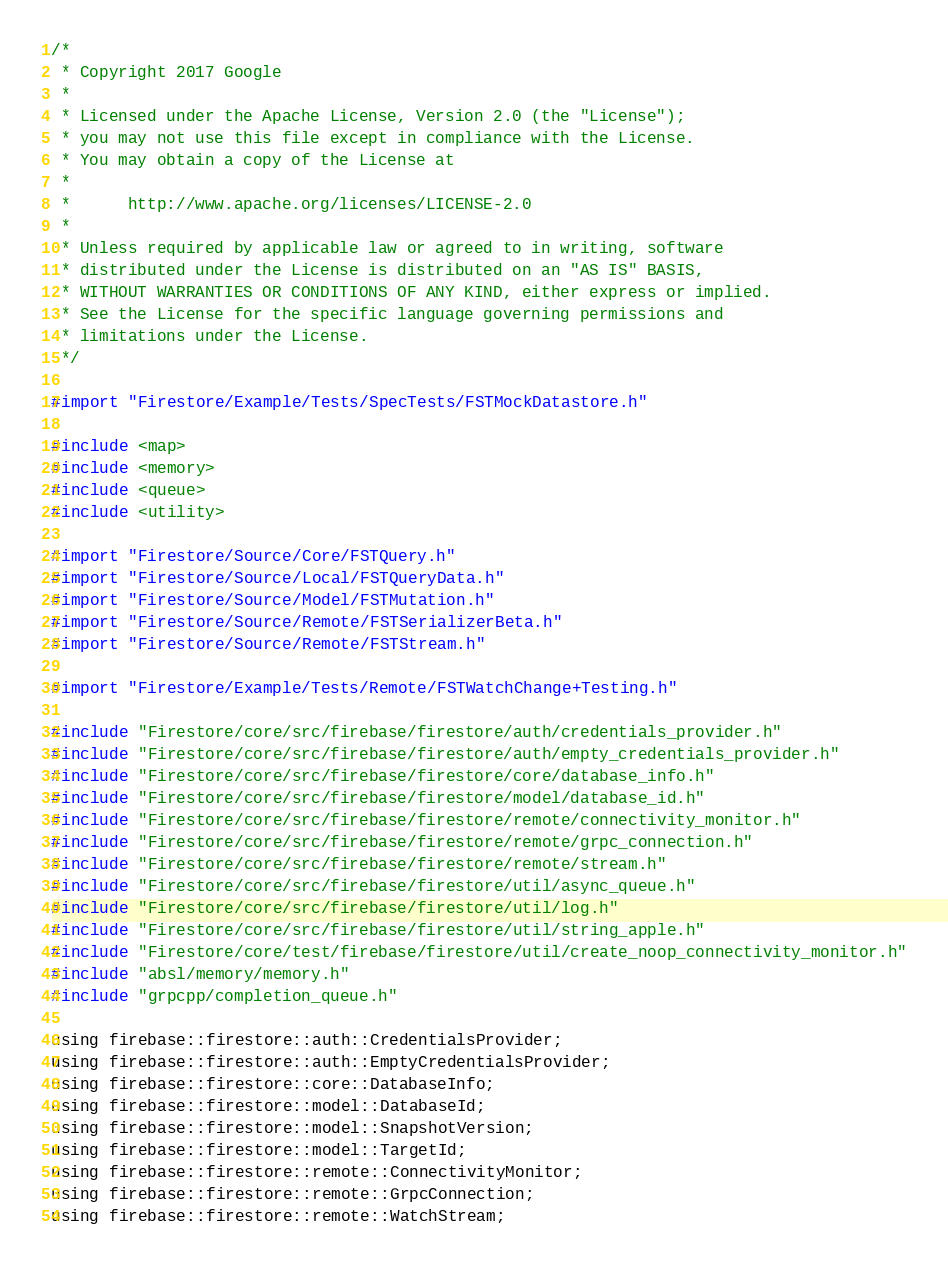<code> <loc_0><loc_0><loc_500><loc_500><_ObjectiveC_>/*
 * Copyright 2017 Google
 *
 * Licensed under the Apache License, Version 2.0 (the "License");
 * you may not use this file except in compliance with the License.
 * You may obtain a copy of the License at
 *
 *      http://www.apache.org/licenses/LICENSE-2.0
 *
 * Unless required by applicable law or agreed to in writing, software
 * distributed under the License is distributed on an "AS IS" BASIS,
 * WITHOUT WARRANTIES OR CONDITIONS OF ANY KIND, either express or implied.
 * See the License for the specific language governing permissions and
 * limitations under the License.
 */

#import "Firestore/Example/Tests/SpecTests/FSTMockDatastore.h"

#include <map>
#include <memory>
#include <queue>
#include <utility>

#import "Firestore/Source/Core/FSTQuery.h"
#import "Firestore/Source/Local/FSTQueryData.h"
#import "Firestore/Source/Model/FSTMutation.h"
#import "Firestore/Source/Remote/FSTSerializerBeta.h"
#import "Firestore/Source/Remote/FSTStream.h"

#import "Firestore/Example/Tests/Remote/FSTWatchChange+Testing.h"

#include "Firestore/core/src/firebase/firestore/auth/credentials_provider.h"
#include "Firestore/core/src/firebase/firestore/auth/empty_credentials_provider.h"
#include "Firestore/core/src/firebase/firestore/core/database_info.h"
#include "Firestore/core/src/firebase/firestore/model/database_id.h"
#include "Firestore/core/src/firebase/firestore/remote/connectivity_monitor.h"
#include "Firestore/core/src/firebase/firestore/remote/grpc_connection.h"
#include "Firestore/core/src/firebase/firestore/remote/stream.h"
#include "Firestore/core/src/firebase/firestore/util/async_queue.h"
#include "Firestore/core/src/firebase/firestore/util/log.h"
#include "Firestore/core/src/firebase/firestore/util/string_apple.h"
#include "Firestore/core/test/firebase/firestore/util/create_noop_connectivity_monitor.h"
#include "absl/memory/memory.h"
#include "grpcpp/completion_queue.h"

using firebase::firestore::auth::CredentialsProvider;
using firebase::firestore::auth::EmptyCredentialsProvider;
using firebase::firestore::core::DatabaseInfo;
using firebase::firestore::model::DatabaseId;
using firebase::firestore::model::SnapshotVersion;
using firebase::firestore::model::TargetId;
using firebase::firestore::remote::ConnectivityMonitor;
using firebase::firestore::remote::GrpcConnection;
using firebase::firestore::remote::WatchStream;</code> 